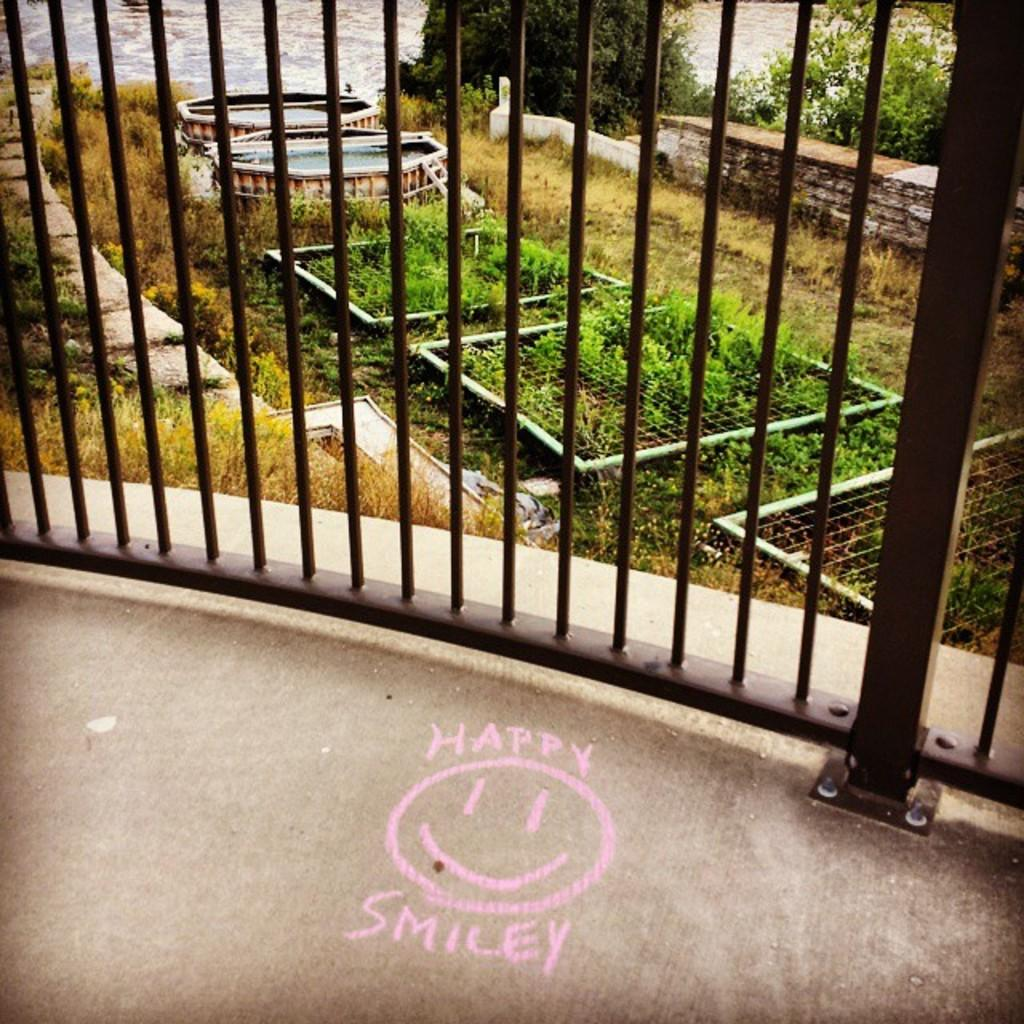What type of structures are present in the image? There are grilles in the image. What type of vegetation can be seen in the image? There are plants in the image. What can be seen in the background of the image? There are trees and walls visible in the background of the image. What type of steam can be seen rising from the grilles in the image? There is no steam present in the image; only grilles and plants are visible. 